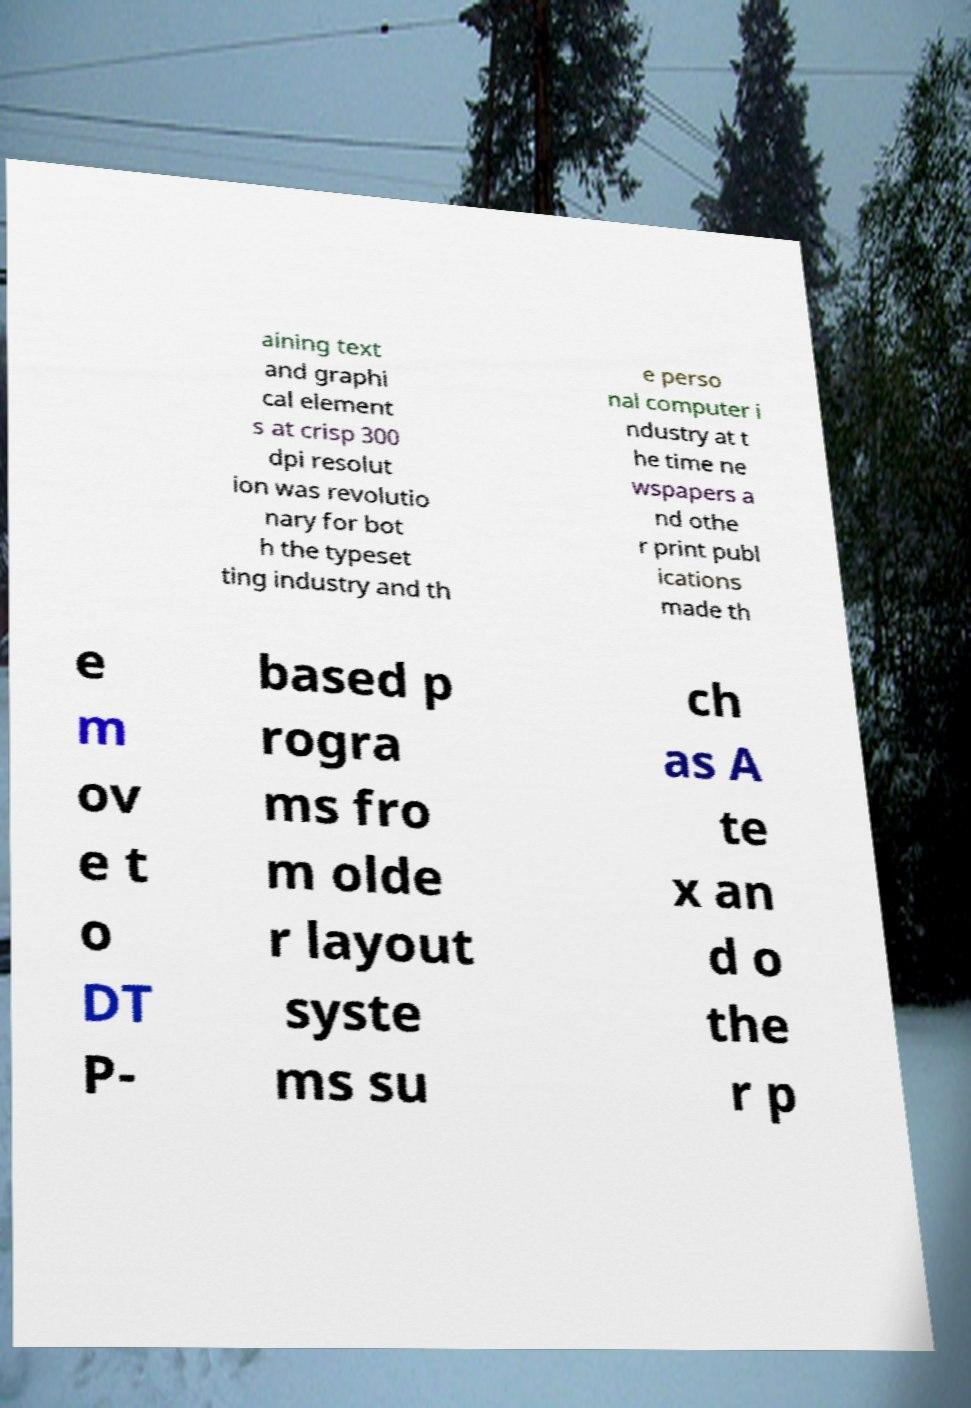Can you accurately transcribe the text from the provided image for me? aining text and graphi cal element s at crisp 300 dpi resolut ion was revolutio nary for bot h the typeset ting industry and th e perso nal computer i ndustry at t he time ne wspapers a nd othe r print publ ications made th e m ov e t o DT P- based p rogra ms fro m olde r layout syste ms su ch as A te x an d o the r p 